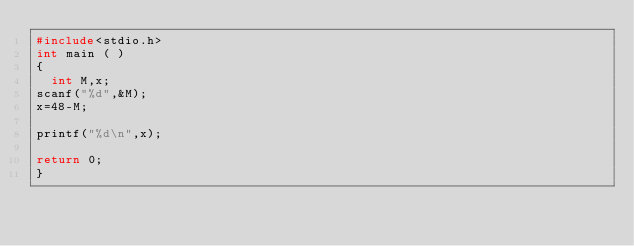<code> <loc_0><loc_0><loc_500><loc_500><_C_>#include<stdio.h>
int main ( )
{
  int M,x;
scanf("%d",&M);
x=48-M;

printf("%d\n",x);

return 0;
}</code> 